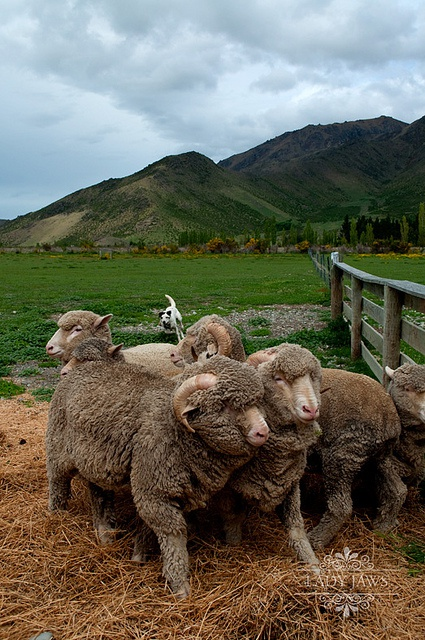Describe the objects in this image and their specific colors. I can see sheep in lightblue, black, gray, and maroon tones, sheep in lightblue, black, maroon, and gray tones, sheep in lightblue, black, maroon, and gray tones, sheep in lightblue, black, gray, and maroon tones, and sheep in lightblue, tan, and gray tones in this image. 